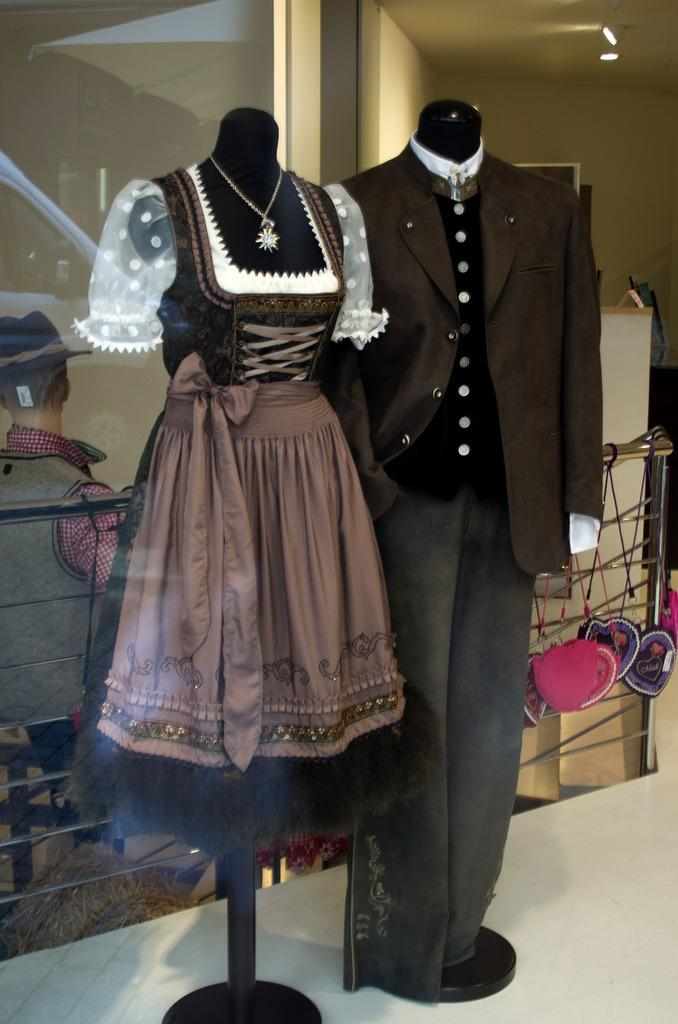How many mannequins are in the image? There are two mannequins in the image. What are the mannequins wearing? One mannequin is wearing a gown, and the other mannequin is wearing a suit. Can you describe the person sitting on a chair in the image? There is a person sitting on a chair in the image, but no specific details about their appearance or clothing are provided. What can be seen attached to the fence on the right side of the image? There are bags attached to a fence on the right side of the image. What type of owl can be seen perched on the mannequin wearing a gown? There is no owl present in the image; it features two mannequins, one wearing a gown and the other wearing a suit. Is there any snow visible in the image? There is no mention of snow in the provided facts, and no snow is visible in the image. 